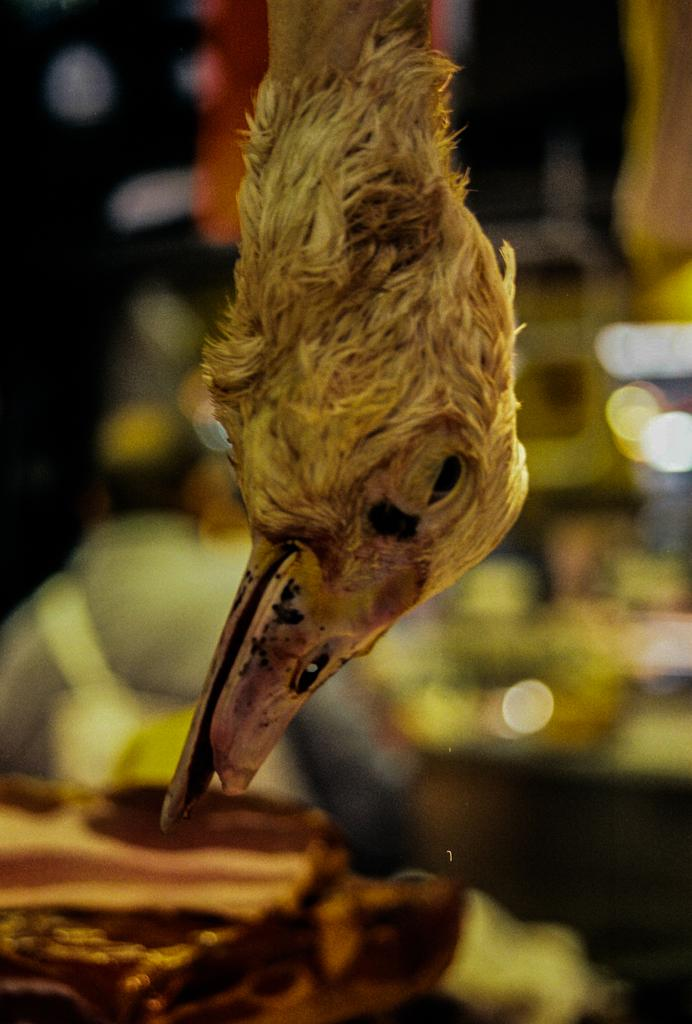What part of an animal can be seen in the image? There is a beak of an animal in the image. How many children are playing with the beak in the image? There are no children present in the image, as it only features the beak of an animal. 